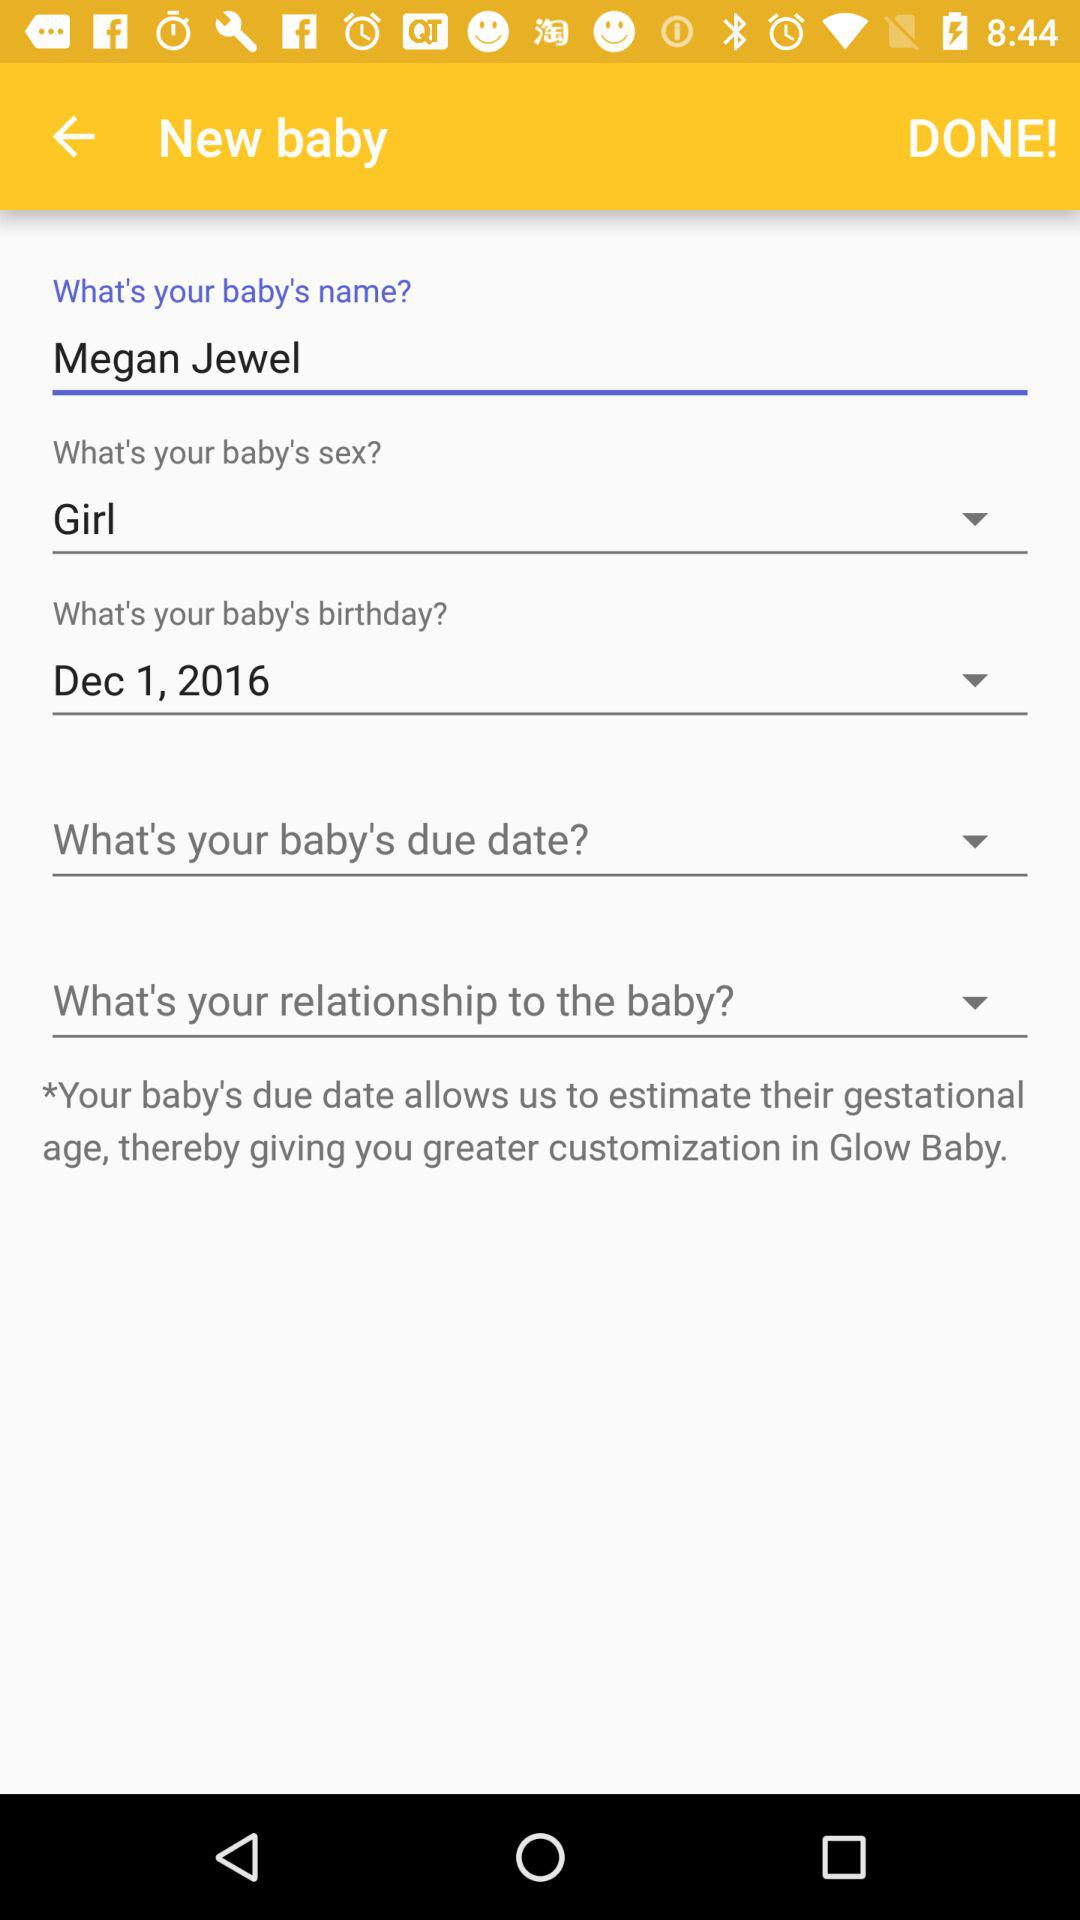What is the baby's gender? The baby is a girl. 